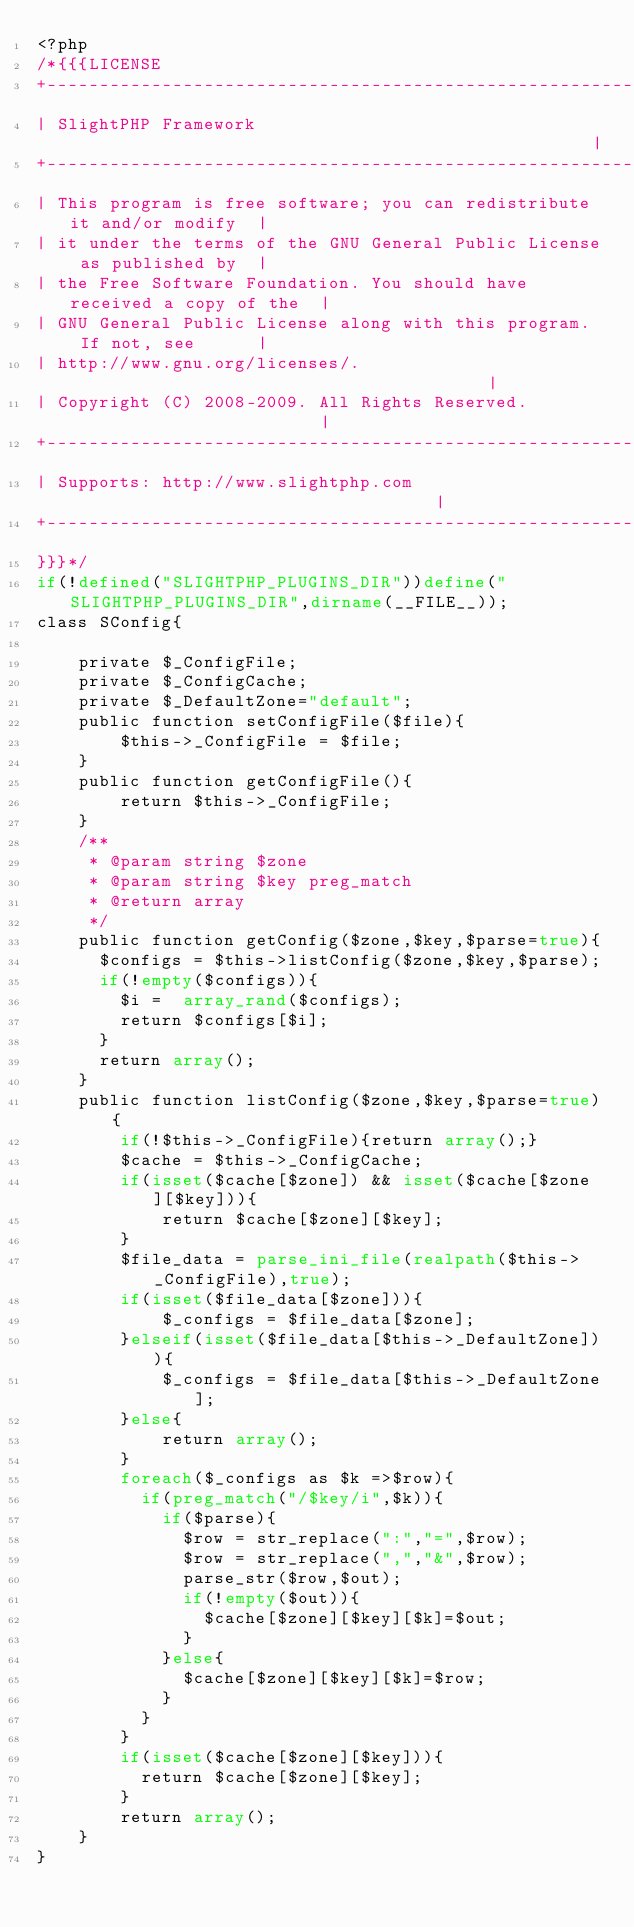<code> <loc_0><loc_0><loc_500><loc_500><_PHP_><?php
/*{{{LICENSE
+-----------------------------------------------------------------------+
| SlightPHP Framework                                                   |
+-----------------------------------------------------------------------+
| This program is free software; you can redistribute it and/or modify  |
| it under the terms of the GNU General Public License as published by  |
| the Free Software Foundation. You should have received a copy of the  |
| GNU General Public License along with this program.  If not, see      |
| http://www.gnu.org/licenses/.                                         |
| Copyright (C) 2008-2009. All Rights Reserved.                         |
+-----------------------------------------------------------------------+
| Supports: http://www.slightphp.com                                    |
+-----------------------------------------------------------------------+
}}}*/
if(!defined("SLIGHTPHP_PLUGINS_DIR"))define("SLIGHTPHP_PLUGINS_DIR",dirname(__FILE__));
class SConfig{

		private $_ConfigFile;
		private $_ConfigCache;
		private $_DefaultZone="default";
		public function setConfigFile($file){
				$this->_ConfigFile = $file;
		}
		public function getConfigFile(){
				return $this->_ConfigFile;
		}
		/**
		 * @param string $zone
		 * @param string $key preg_match
		 * @return array
		 */
		public function getConfig($zone,$key,$parse=true){
			$configs = $this->listConfig($zone,$key,$parse);
			if(!empty($configs)){
				$i =  array_rand($configs);
				return $configs[$i];
			}
			return array();
		}
		public function listConfig($zone,$key,$parse=true){
				if(!$this->_ConfigFile){return array();}
				$cache = $this->_ConfigCache;
				if(isset($cache[$zone]) && isset($cache[$zone][$key])){
						return $cache[$zone][$key];
				}
				$file_data = parse_ini_file(realpath($this->_ConfigFile),true);
				if(isset($file_data[$zone])){
						$_configs = $file_data[$zone];
				}elseif(isset($file_data[$this->_DefaultZone])){
						$_configs = $file_data[$this->_DefaultZone];
				}else{
						return array();
				}
				foreach($_configs as $k =>$row){
					if(preg_match("/$key/i",$k)){
						if($parse){
							$row = str_replace(":","=",$row);
							$row = str_replace(",","&",$row);
							parse_str($row,$out);
							if(!empty($out)){
								$cache[$zone][$key][$k]=$out;
							}
						}else{
							$cache[$zone][$key][$k]=$row;
						}
					}
				}
				if(isset($cache[$zone][$key])){
					return $cache[$zone][$key];
				}
				return array();
		}
}
</code> 